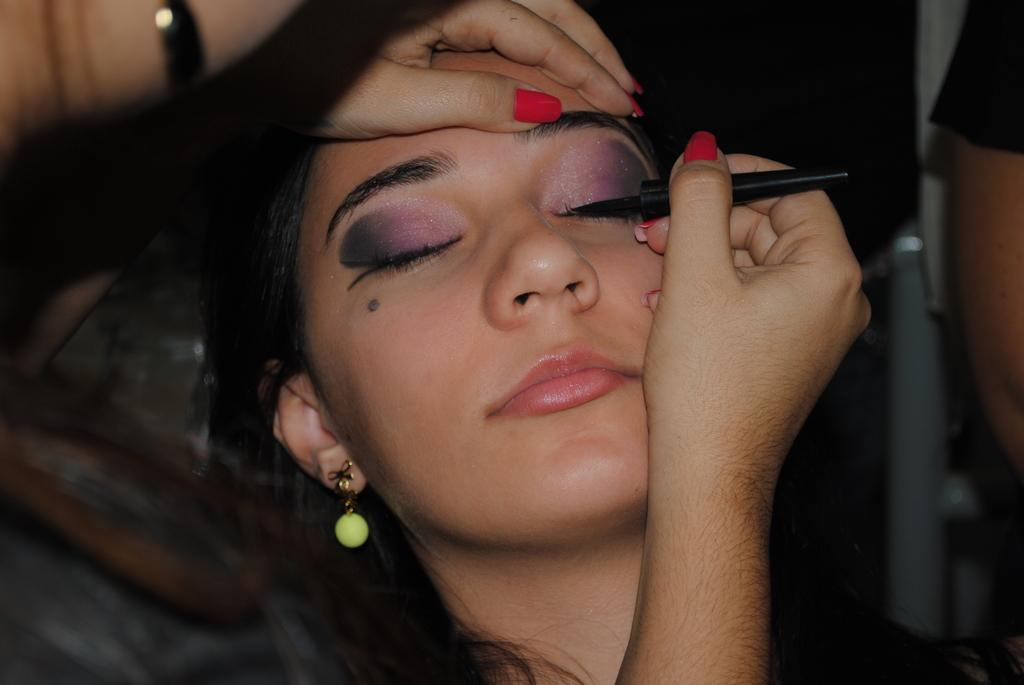Who is the main subject in the image? There is a girl in the image. What is the girl doing in the image? The girl is makeuping another girl. Can you describe the background of the image? The background of the image is blurred. What type of meal is being prepared by the government in the image? There is no mention of a meal or the government in the image; it features a girl makeuping another girl with a blurred background. 